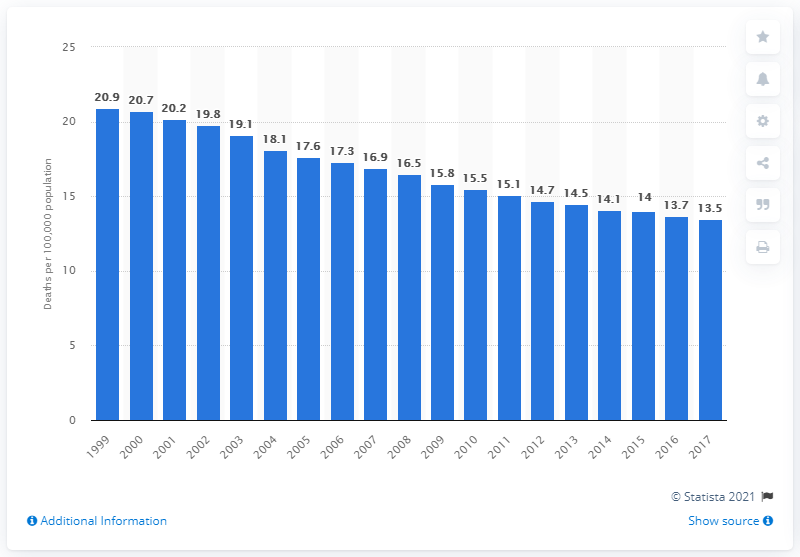Identify some key points in this picture. In 2017, the minimum rate of colon and rectum cancer deaths in the United States was 13.5 per 100,000 population. 